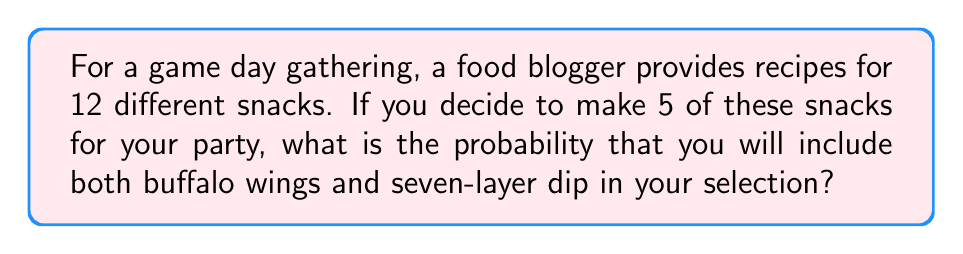Can you solve this math problem? Let's approach this step-by-step using the concept of combinations:

1) First, we need to calculate the total number of ways to choose 5 snacks out of 12. This is given by the combination formula:

   $$\binom{12}{5} = \frac{12!}{5!(12-5)!} = \frac{12!}{5!7!} = 792$$

2) Now, we need to calculate the number of ways to choose the remaining 3 snacks out of the 10 left (since buffalo wings and seven-layer dip are already chosen). This is:

   $$\binom{10}{3} = \frac{10!}{3!(10-3)!} = \frac{10!}{3!7!} = 120$$

3) The probability is then the number of favorable outcomes divided by the total number of possible outcomes:

   $$P(\text{buffalo wings and seven-layer dip}) = \frac{\binom{10}{3}}{\binom{12}{5}} = \frac{120}{792} = \frac{15}{99} \approx 0.1515$$

4) This can be simplified to:

   $$\frac{15}{99} = \frac{5}{33}$$

Therefore, the probability of including both buffalo wings and seven-layer dip in your selection is $\frac{5}{33}$ or approximately 15.15%.
Answer: $\frac{5}{33}$ 